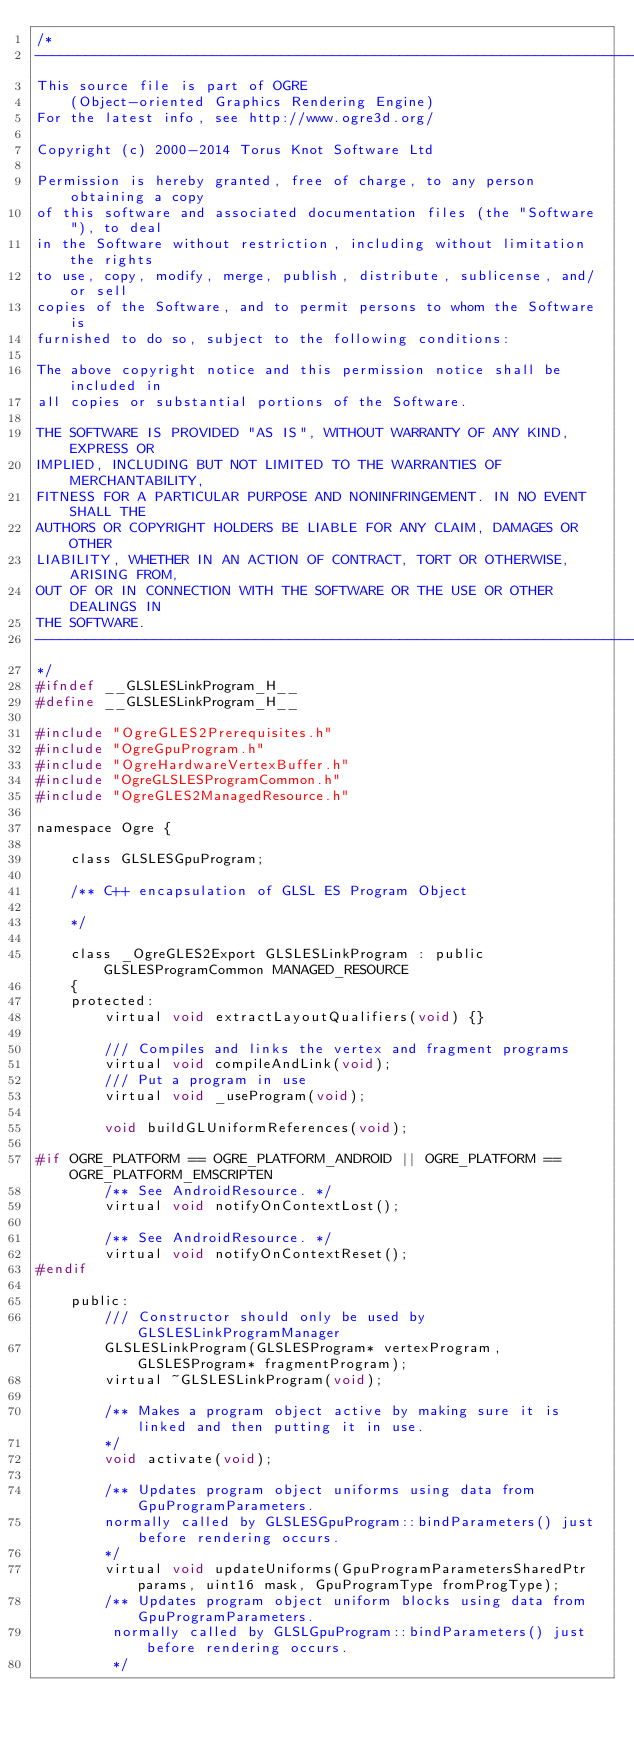<code> <loc_0><loc_0><loc_500><loc_500><_C_>/*
-----------------------------------------------------------------------------
This source file is part of OGRE
    (Object-oriented Graphics Rendering Engine)
For the latest info, see http://www.ogre3d.org/

Copyright (c) 2000-2014 Torus Knot Software Ltd

Permission is hereby granted, free of charge, to any person obtaining a copy
of this software and associated documentation files (the "Software"), to deal
in the Software without restriction, including without limitation the rights
to use, copy, modify, merge, publish, distribute, sublicense, and/or sell
copies of the Software, and to permit persons to whom the Software is
furnished to do so, subject to the following conditions:

The above copyright notice and this permission notice shall be included in
all copies or substantial portions of the Software.

THE SOFTWARE IS PROVIDED "AS IS", WITHOUT WARRANTY OF ANY KIND, EXPRESS OR
IMPLIED, INCLUDING BUT NOT LIMITED TO THE WARRANTIES OF MERCHANTABILITY,
FITNESS FOR A PARTICULAR PURPOSE AND NONINFRINGEMENT. IN NO EVENT SHALL THE
AUTHORS OR COPYRIGHT HOLDERS BE LIABLE FOR ANY CLAIM, DAMAGES OR OTHER
LIABILITY, WHETHER IN AN ACTION OF CONTRACT, TORT OR OTHERWISE, ARISING FROM,
OUT OF OR IN CONNECTION WITH THE SOFTWARE OR THE USE OR OTHER DEALINGS IN
THE SOFTWARE.
-----------------------------------------------------------------------------
*/
#ifndef __GLSLESLinkProgram_H__
#define __GLSLESLinkProgram_H__

#include "OgreGLES2Prerequisites.h"
#include "OgreGpuProgram.h"
#include "OgreHardwareVertexBuffer.h"
#include "OgreGLSLESProgramCommon.h"
#include "OgreGLES2ManagedResource.h"

namespace Ogre {
    
    class GLSLESGpuProgram;

    /** C++ encapsulation of GLSL ES Program Object

    */

    class _OgreGLES2Export GLSLESLinkProgram : public GLSLESProgramCommon MANAGED_RESOURCE
    {
    protected:
        virtual void extractLayoutQualifiers(void) {}

        /// Compiles and links the vertex and fragment programs
        virtual void compileAndLink(void);
        /// Put a program in use
        virtual void _useProgram(void);

        void buildGLUniformReferences(void);

#if OGRE_PLATFORM == OGRE_PLATFORM_ANDROID || OGRE_PLATFORM == OGRE_PLATFORM_EMSCRIPTEN
        /** See AndroidResource. */
        virtual void notifyOnContextLost();
        
        /** See AndroidResource. */
        virtual void notifyOnContextReset();
#endif
        
    public:
        /// Constructor should only be used by GLSLESLinkProgramManager
        GLSLESLinkProgram(GLSLESProgram* vertexProgram, GLSLESProgram* fragmentProgram);
        virtual ~GLSLESLinkProgram(void);

        /** Makes a program object active by making sure it is linked and then putting it in use.
        */
        void activate(void);

        /** Updates program object uniforms using data from GpuProgramParameters.
        normally called by GLSLESGpuProgram::bindParameters() just before rendering occurs.
        */
        virtual void updateUniforms(GpuProgramParametersSharedPtr params, uint16 mask, GpuProgramType fromProgType);
        /** Updates program object uniform blocks using data from GpuProgramParameters.
         normally called by GLSLGpuProgram::bindParameters() just before rendering occurs.
         */</code> 